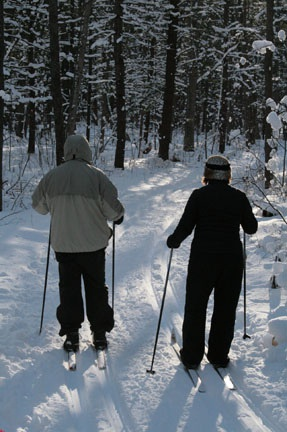Describe the objects in this image and their specific colors. I can see people in black, gray, and purple tones, people in black, darkgray, gray, and lightgray tones, skis in black, gray, lightgray, and darkgray tones, and skis in black, darkgray, gray, and lightgray tones in this image. 